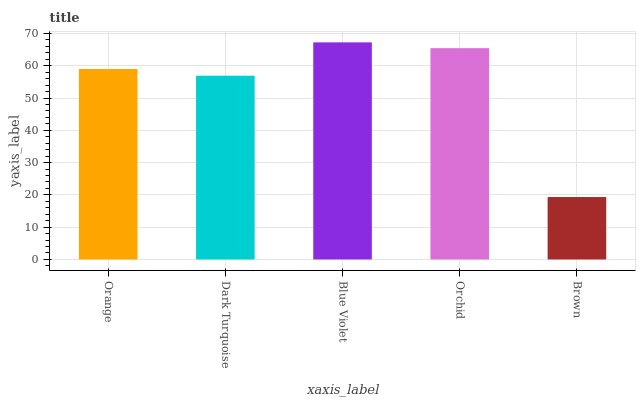Is Blue Violet the maximum?
Answer yes or no. Yes. Is Dark Turquoise the minimum?
Answer yes or no. No. Is Dark Turquoise the maximum?
Answer yes or no. No. Is Orange greater than Dark Turquoise?
Answer yes or no. Yes. Is Dark Turquoise less than Orange?
Answer yes or no. Yes. Is Dark Turquoise greater than Orange?
Answer yes or no. No. Is Orange less than Dark Turquoise?
Answer yes or no. No. Is Orange the high median?
Answer yes or no. Yes. Is Orange the low median?
Answer yes or no. Yes. Is Blue Violet the high median?
Answer yes or no. No. Is Orchid the low median?
Answer yes or no. No. 